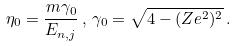Convert formula to latex. <formula><loc_0><loc_0><loc_500><loc_500>\eta _ { 0 } = \frac { m \gamma _ { 0 } } { E _ { n , j } } \, , \, \gamma _ { 0 } = \sqrt { 4 - ( Z e ^ { 2 } ) ^ { 2 } } \, .</formula> 